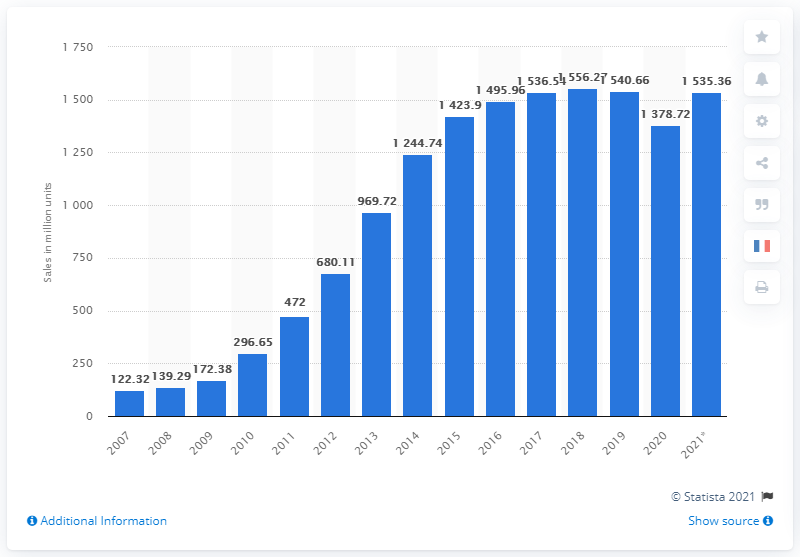Point out several critical features in this image. In 2020, a total of 1378.72 million smartphones were sold worldwide. 